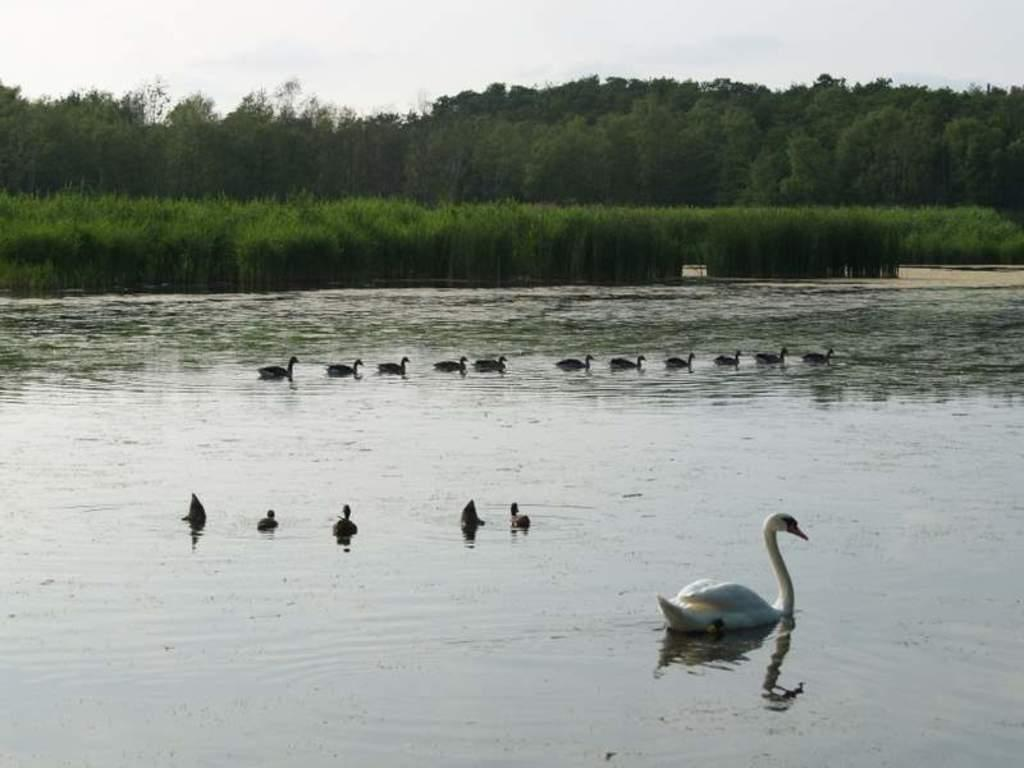What type of animals can be seen in the image? Birds can be seen in the water. What can be seen in the background of the image? There are plants, trees, and the sky visible in the background of the image. How do the sisters interact with the birds in the image? There is no mention of sisters in the image, so we cannot answer this question. 